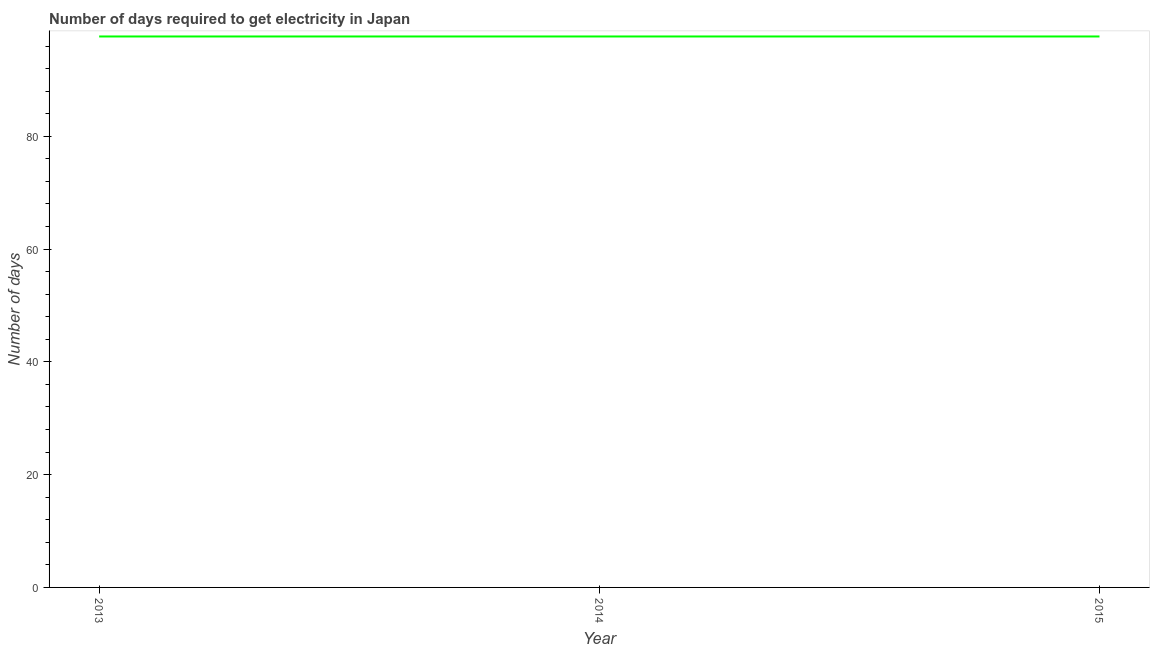What is the time to get electricity in 2013?
Give a very brief answer. 97.7. Across all years, what is the maximum time to get electricity?
Provide a succinct answer. 97.7. Across all years, what is the minimum time to get electricity?
Make the answer very short. 97.7. In which year was the time to get electricity maximum?
Offer a very short reply. 2013. What is the sum of the time to get electricity?
Your response must be concise. 293.1. What is the average time to get electricity per year?
Provide a short and direct response. 97.7. What is the median time to get electricity?
Your response must be concise. 97.7. Do a majority of the years between 2015 and 2014 (inclusive) have time to get electricity greater than 24 ?
Make the answer very short. No. What is the ratio of the time to get electricity in 2014 to that in 2015?
Make the answer very short. 1. Is the difference between the time to get electricity in 2013 and 2014 greater than the difference between any two years?
Provide a succinct answer. Yes. What is the difference between the highest and the lowest time to get electricity?
Provide a short and direct response. 0. Does the graph contain any zero values?
Offer a very short reply. No. What is the title of the graph?
Provide a succinct answer. Number of days required to get electricity in Japan. What is the label or title of the Y-axis?
Your answer should be compact. Number of days. What is the Number of days of 2013?
Ensure brevity in your answer.  97.7. What is the Number of days of 2014?
Make the answer very short. 97.7. What is the Number of days in 2015?
Keep it short and to the point. 97.7. What is the difference between the Number of days in 2013 and 2014?
Ensure brevity in your answer.  0. What is the ratio of the Number of days in 2013 to that in 2015?
Offer a terse response. 1. 